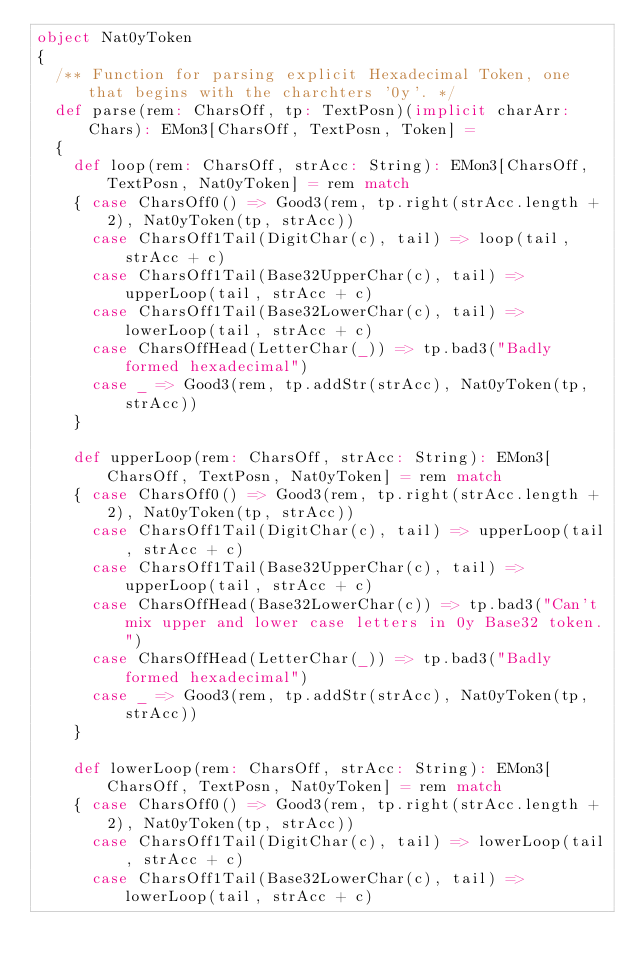Convert code to text. <code><loc_0><loc_0><loc_500><loc_500><_Scala_>object Nat0yToken
{
  /** Function for parsing explicit Hexadecimal Token, one that begins with the charchters '0y'. */
  def parse(rem: CharsOff, tp: TextPosn)(implicit charArr: Chars): EMon3[CharsOff, TextPosn, Token] =
  {
    def loop(rem: CharsOff, strAcc: String): EMon3[CharsOff, TextPosn, Nat0yToken] = rem match
    { case CharsOff0() => Good3(rem, tp.right(strAcc.length + 2), Nat0yToken(tp, strAcc))
      case CharsOff1Tail(DigitChar(c), tail) => loop(tail, strAcc + c)
      case CharsOff1Tail(Base32UpperChar(c), tail) => upperLoop(tail, strAcc + c)
      case CharsOff1Tail(Base32LowerChar(c), tail) => lowerLoop(tail, strAcc + c)
      case CharsOffHead(LetterChar(_)) => tp.bad3("Badly formed hexadecimal")
      case _ => Good3(rem, tp.addStr(strAcc), Nat0yToken(tp, strAcc))
    }

    def upperLoop(rem: CharsOff, strAcc: String): EMon3[CharsOff, TextPosn, Nat0yToken] = rem match
    { case CharsOff0() => Good3(rem, tp.right(strAcc.length + 2), Nat0yToken(tp, strAcc))
      case CharsOff1Tail(DigitChar(c), tail) => upperLoop(tail, strAcc + c)
      case CharsOff1Tail(Base32UpperChar(c), tail) => upperLoop(tail, strAcc + c)
      case CharsOffHead(Base32LowerChar(c)) => tp.bad3("Can't mix upper and lower case letters in 0y Base32 token.")
      case CharsOffHead(LetterChar(_)) => tp.bad3("Badly formed hexadecimal")
      case _ => Good3(rem, tp.addStr(strAcc), Nat0yToken(tp, strAcc))
    }

    def lowerLoop(rem: CharsOff, strAcc: String): EMon3[CharsOff, TextPosn, Nat0yToken] = rem match
    { case CharsOff0() => Good3(rem, tp.right(strAcc.length + 2), Nat0yToken(tp, strAcc))
      case CharsOff1Tail(DigitChar(c), tail) => lowerLoop(tail, strAcc + c)
      case CharsOff1Tail(Base32LowerChar(c), tail) => lowerLoop(tail, strAcc + c)</code> 